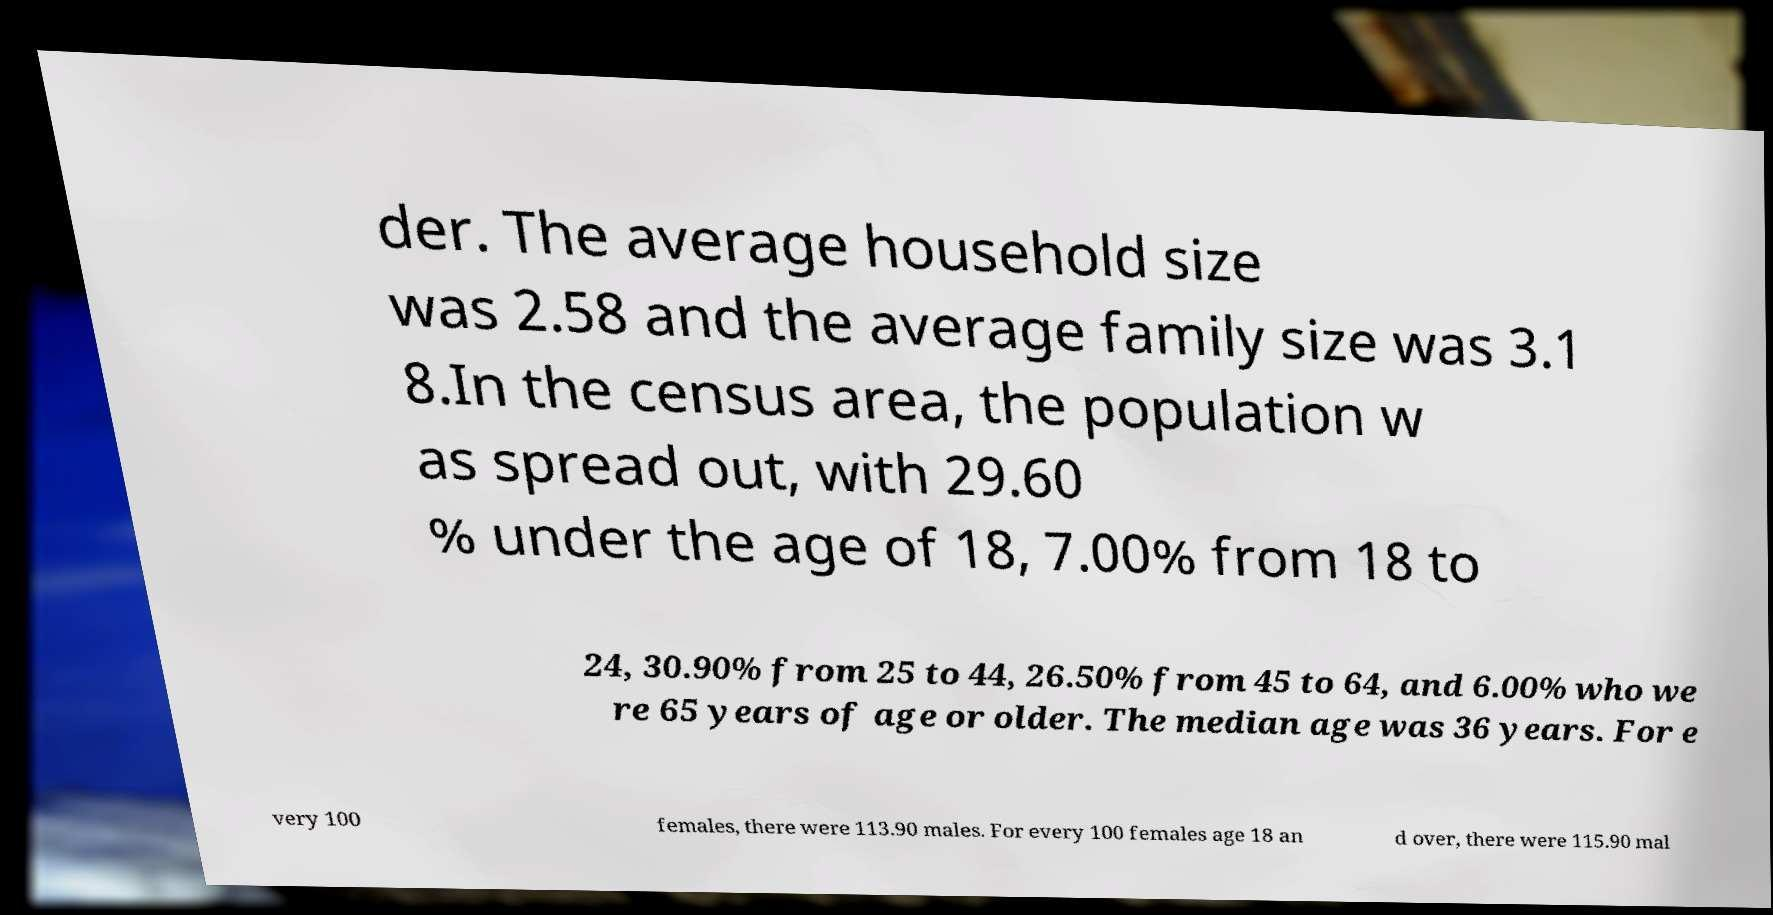Can you accurately transcribe the text from the provided image for me? der. The average household size was 2.58 and the average family size was 3.1 8.In the census area, the population w as spread out, with 29.60 % under the age of 18, 7.00% from 18 to 24, 30.90% from 25 to 44, 26.50% from 45 to 64, and 6.00% who we re 65 years of age or older. The median age was 36 years. For e very 100 females, there were 113.90 males. For every 100 females age 18 an d over, there were 115.90 mal 